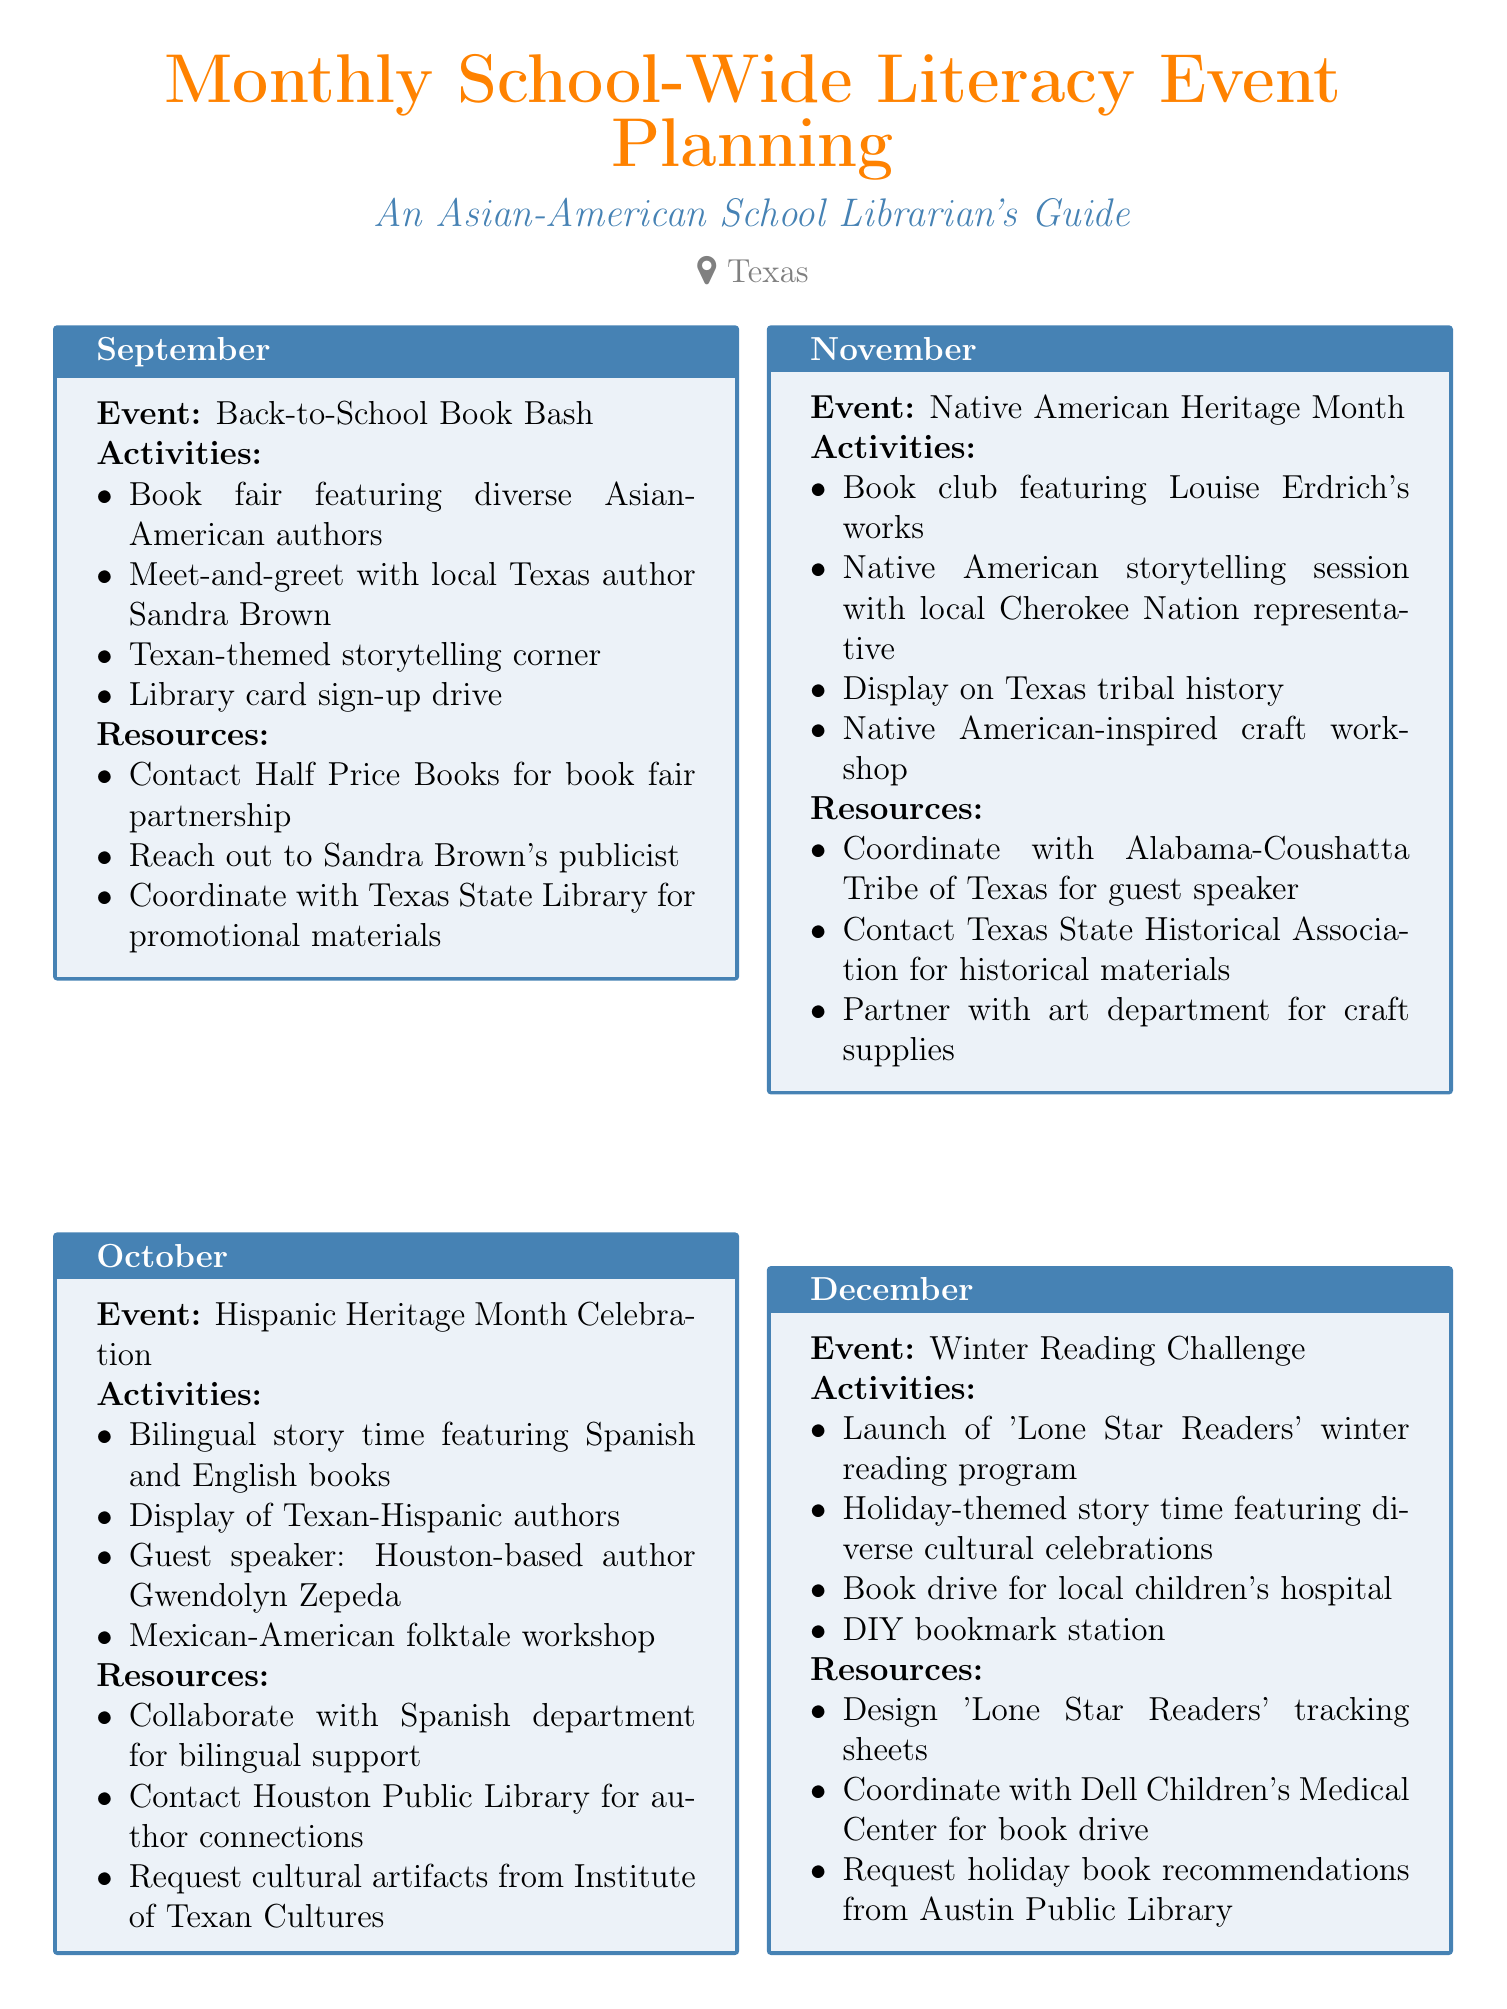what is the event in September? The document lists the event for September as the "Back-to-School Book Bash."
Answer: Back-to-School Book Bash who is a guest speaker for October? The document specifies that the guest speaker for October is Gwendolyn Zepeda.
Answer: Gwendolyn Zepeda how many activities are listed for the May event? The document outlines four activities for the May event.
Answer: four what is the theme of the January event? The event in January is themed "New Year, New Books."
Answer: New Year, New Books which month features poetry-related activities? The document states that April is the month featuring poetry-related activities, specifically "National Poetry Month."
Answer: April what type of workshop is included in the November event? The workshop mentioned for the November event is a "Native American-inspired craft workshop."
Answer: Native American-inspired craft workshop who should be contacted for the Asian-American author fair? The document advises contacting local Asian-American authors through the Texas Library Association.
Answer: Texas Library Association 